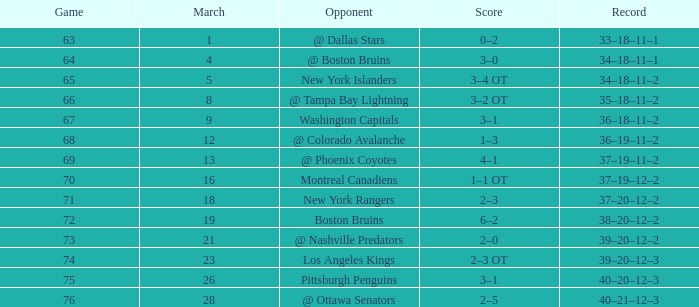Which Opponent has a Record of 38–20–12–2? Boston Bruins. Parse the table in full. {'header': ['Game', 'March', 'Opponent', 'Score', 'Record'], 'rows': [['63', '1', '@ Dallas Stars', '0–2', '33–18–11–1'], ['64', '4', '@ Boston Bruins', '3–0', '34–18–11–1'], ['65', '5', 'New York Islanders', '3–4 OT', '34–18–11–2'], ['66', '8', '@ Tampa Bay Lightning', '3–2 OT', '35–18–11–2'], ['67', '9', 'Washington Capitals', '3–1', '36–18–11–2'], ['68', '12', '@ Colorado Avalanche', '1–3', '36–19–11–2'], ['69', '13', '@ Phoenix Coyotes', '4–1', '37–19–11–2'], ['70', '16', 'Montreal Canadiens', '1–1 OT', '37–19–12–2'], ['71', '18', 'New York Rangers', '2–3', '37–20–12–2'], ['72', '19', 'Boston Bruins', '6–2', '38–20–12–2'], ['73', '21', '@ Nashville Predators', '2–0', '39–20–12–2'], ['74', '23', 'Los Angeles Kings', '2–3 OT', '39–20–12–3'], ['75', '26', 'Pittsburgh Penguins', '3–1', '40–20–12–3'], ['76', '28', '@ Ottawa Senators', '2–5', '40–21–12–3']]} 